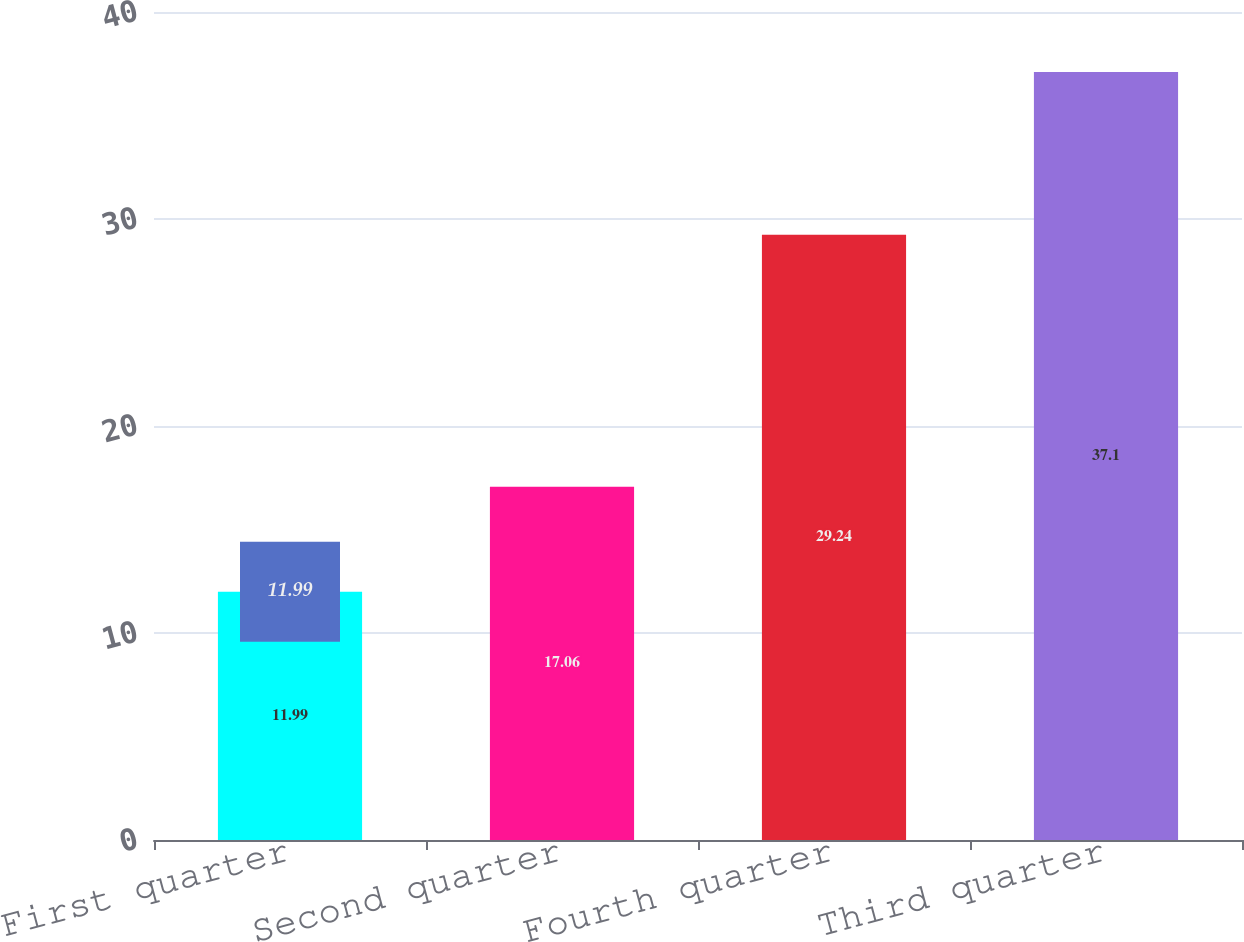Convert chart. <chart><loc_0><loc_0><loc_500><loc_500><bar_chart><fcel>First quarter<fcel>Second quarter<fcel>Fourth quarter<fcel>Third quarter<nl><fcel>11.99<fcel>17.06<fcel>29.24<fcel>37.1<nl></chart> 